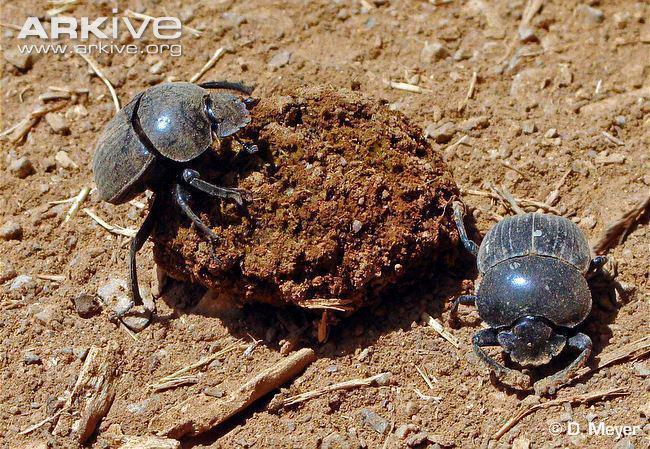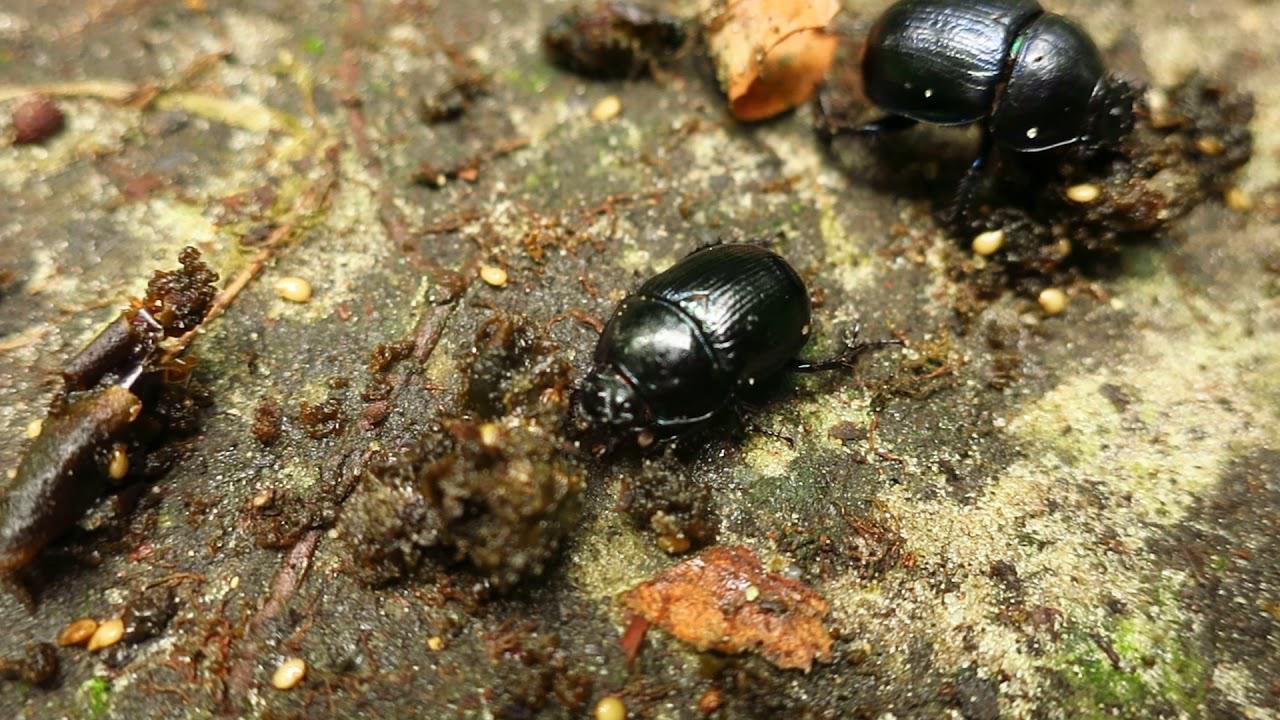The first image is the image on the left, the second image is the image on the right. Assess this claim about the two images: "The left image contains two beetles.". Correct or not? Answer yes or no. Yes. 